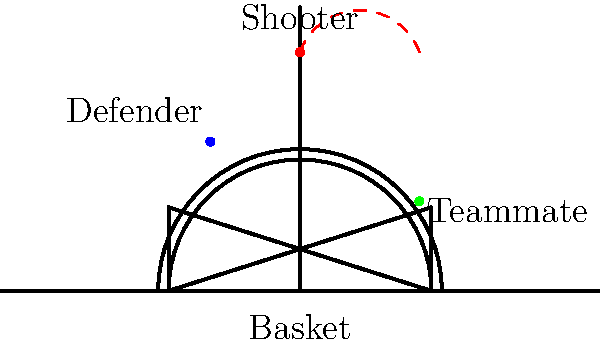Based on the positions of the shooter, defender, and teammate on the basketball court, estimate the most likely trajectory of a successful three-point shot. Consider factors such as the defender's position and the potential for the shooter to create space. How would this trajectory affect the shooter's release point and arc of the shot? To analyze the trajectory of a successful three-point shot in this scenario, we need to consider several factors:

1. Shooter's position: The shooter is positioned at the top of the three-point arc, directly in line with the basket.

2. Defender's position: The defender is positioned to the shooter's left, about halfway between the shooter and the basket.

3. Teammate's position: A teammate is positioned on the right side of the court, closer to the baseline.

4. Creating space: Given the defender's position, the shooter would likely need to create space by moving slightly to their right.

5. Release point: To avoid the defender's reach, the shooter would need to elevate their release point.

6. Arc of the shot: A higher release point typically results in a higher arc, which is beneficial for long-distance shots.

7. Trajectory: The optimal trajectory would be a high arc that peaks slightly past the midpoint between the shooter and the basket.

The most likely trajectory would be a path that starts from a point slightly to the right of the shooter's current position, arcs high over the defender, and descends steeply into the basket. This trajectory allows the shooter to:

a) Avoid the defender's contest
b) Maximize the ball's entry angle into the basket
c) Increase the effective target size of the rim

The release point would be higher than normal, and the arc of the shot would be more pronounced compared to a typical jump shot. This higher arc helps compensate for the longer distance of the three-point shot and reduces the chance of the ball being blocked.
Answer: High arc trajectory, peaking past midpoint, with elevated release point to right of initial position. 